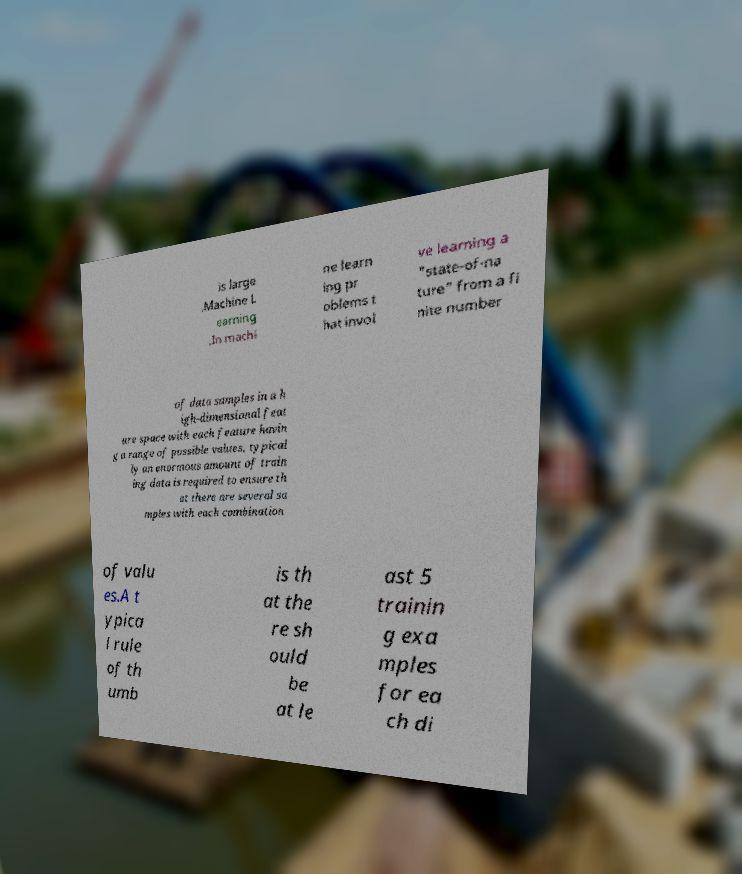Can you read and provide the text displayed in the image?This photo seems to have some interesting text. Can you extract and type it out for me? is large .Machine L earning .In machi ne learn ing pr oblems t hat invol ve learning a "state-of-na ture" from a fi nite number of data samples in a h igh-dimensional feat ure space with each feature havin g a range of possible values, typical ly an enormous amount of train ing data is required to ensure th at there are several sa mples with each combination of valu es.A t ypica l rule of th umb is th at the re sh ould be at le ast 5 trainin g exa mples for ea ch di 